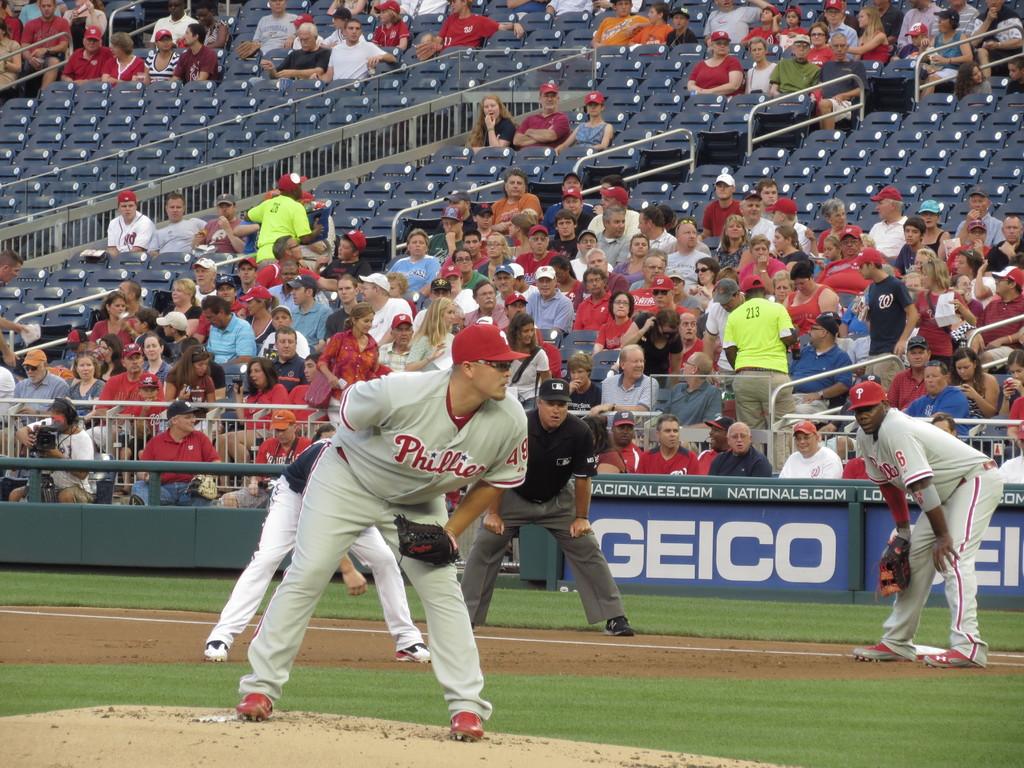What car insurance is advertised at this game?
Offer a terse response. Geico. What team is on the pitcher's jersey?
Ensure brevity in your answer.  Phillies. 